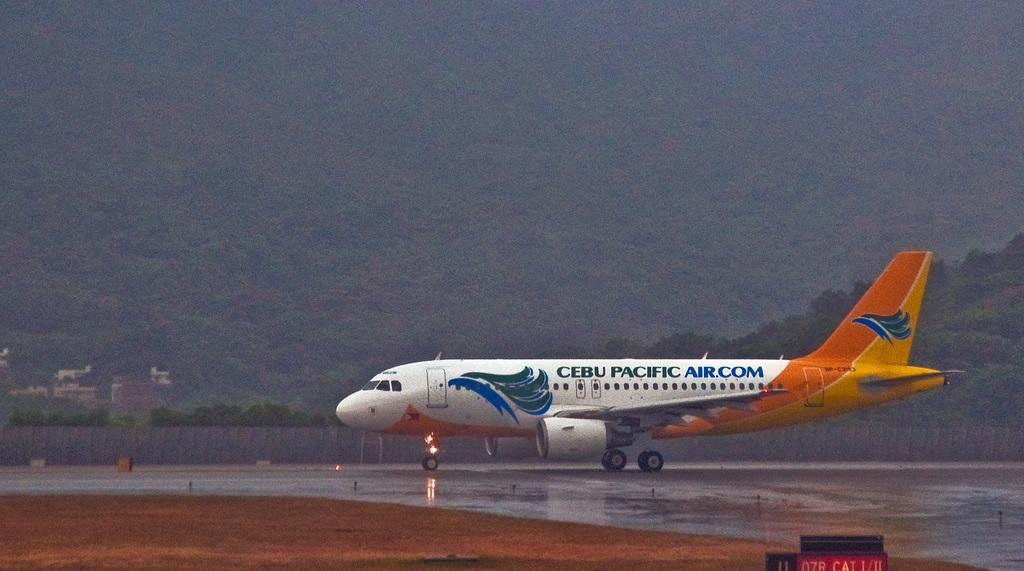<image>
Write a terse but informative summary of the picture. An airplane advertising Cebu Pacific Air,com on its side. 